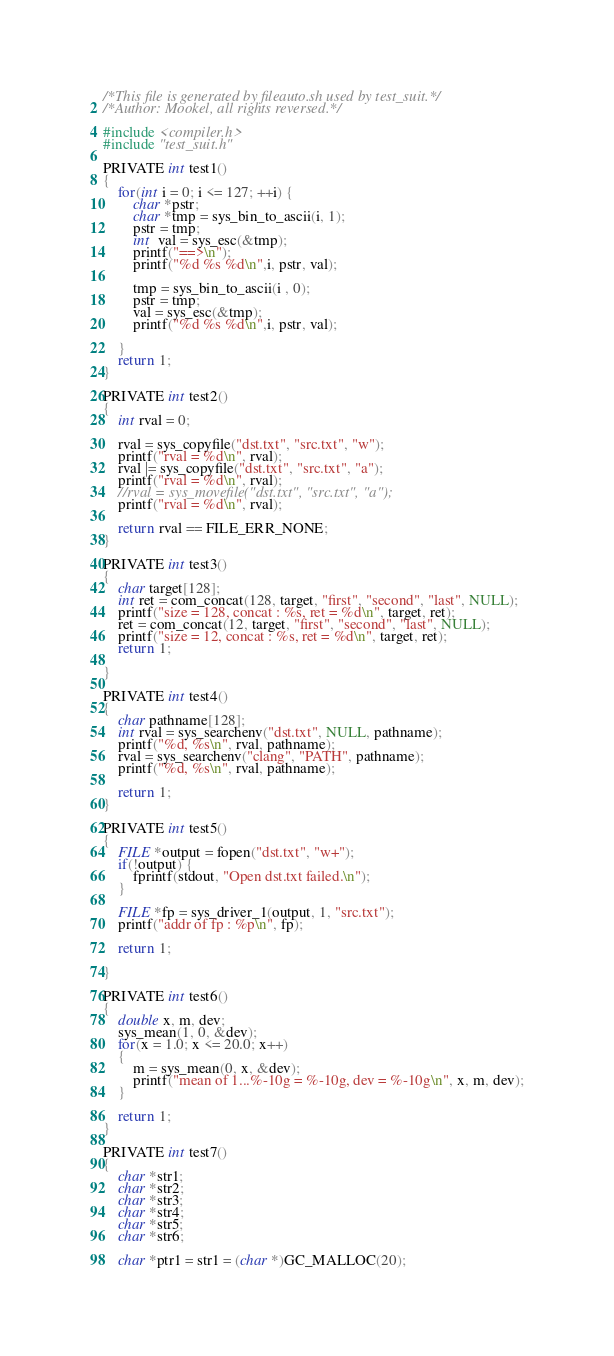<code> <loc_0><loc_0><loc_500><loc_500><_C_>/*This file is generated by fileauto.sh used by test_suit.*/
/*Author: Mookel, all rights reversed.*/

#include <compiler.h>
#include "test_suit.h"

PRIVATE int test1()
{
    for(int i = 0; i <= 127; ++i) {
        char *pstr;
        char *tmp = sys_bin_to_ascii(i, 1);
        pstr = tmp;
        int  val = sys_esc(&tmp);
        printf("==>\n");
        printf("%d %s %d\n",i, pstr, val);

        tmp = sys_bin_to_ascii(i , 0);
        pstr = tmp;
        val = sys_esc(&tmp);
        printf("%d %s %d\n",i, pstr, val);

    }
    return 1;
}

PRIVATE int test2()
{
    int rval = 0;

    rval = sys_copyfile("dst.txt", "src.txt", "w");
    printf("rval = %d\n", rval);
    rval |= sys_copyfile("dst.txt", "src.txt", "a");
    printf("rval = %d\n", rval);
    //rval = sys_movefile("dst.txt", "src.txt", "a");
    printf("rval = %d\n", rval);

    return rval == FILE_ERR_NONE;
}

PRIVATE int test3()
{
    char target[128];
    int ret = com_concat(128, target, "first", "second", "last", NULL);
    printf("size = 128, concat : %s, ret = %d\n", target, ret);
    ret = com_concat(12, target, "first", "second", "last", NULL);
    printf("size = 12, concat : %s, ret = %d\n", target, ret);
    return 1;

}

PRIVATE int test4()
{
    char pathname[128];
    int rval = sys_searchenv("dst.txt", NULL, pathname);
    printf("%d, %s\n", rval, pathname);
    rval = sys_searchenv("clang", "PATH", pathname);
    printf("%d, %s\n", rval, pathname);

    return 1;
}

PRIVATE int test5()
{
    FILE *output = fopen("dst.txt", "w+");
    if(!output) {
        fprintf(stdout, "Open dst.txt failed.\n");
    }

    FILE *fp = sys_driver_1(output, 1, "src.txt");
    printf("addr of fp : %p\n", fp);

    return 1;

}

PRIVATE int test6()
{
    double x, m, dev;
    sys_mean(1, 0, &dev);
    for(x = 1.0; x <= 20.0; x++)
    {
        m = sys_mean(0, x, &dev);
        printf("mean of 1...%-10g = %-10g, dev = %-10g\n", x, m, dev);
    }

    return 1;
}

PRIVATE int test7()
{
    char *str1;
    char *str2;
    char *str3;
    char *str4;
    char *str5;
    char *str6;

    char *ptr1 = str1 = (char *)GC_MALLOC(20);</code> 